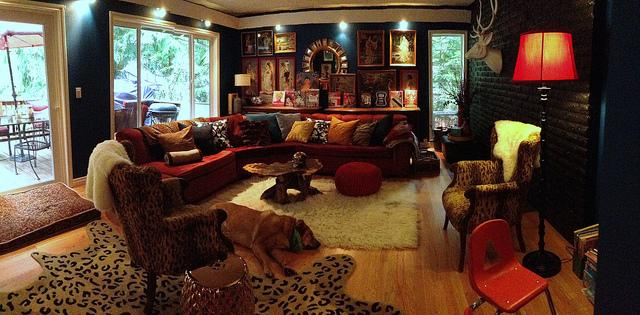What is hanging on the right side of the room?

Choices:
A) goddess statue
B) deer head
C) baseball pennant
D) monkey deer head 